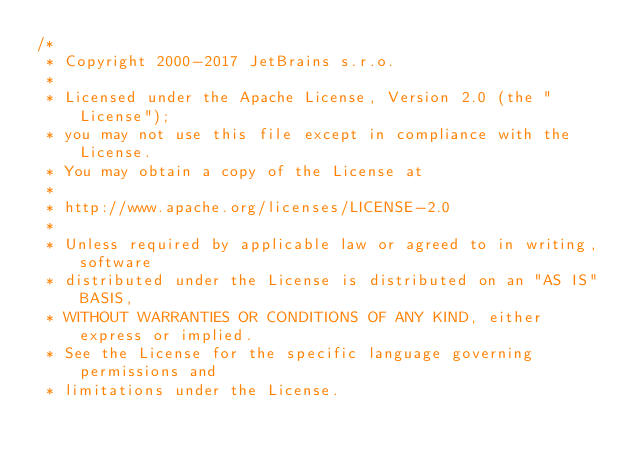<code> <loc_0><loc_0><loc_500><loc_500><_Java_>/*
 * Copyright 2000-2017 JetBrains s.r.o.
 *
 * Licensed under the Apache License, Version 2.0 (the "License");
 * you may not use this file except in compliance with the License.
 * You may obtain a copy of the License at
 *
 * http://www.apache.org/licenses/LICENSE-2.0
 *
 * Unless required by applicable law or agreed to in writing, software
 * distributed under the License is distributed on an "AS IS" BASIS,
 * WITHOUT WARRANTIES OR CONDITIONS OF ANY KIND, either express or implied.
 * See the License for the specific language governing permissions and
 * limitations under the License.</code> 